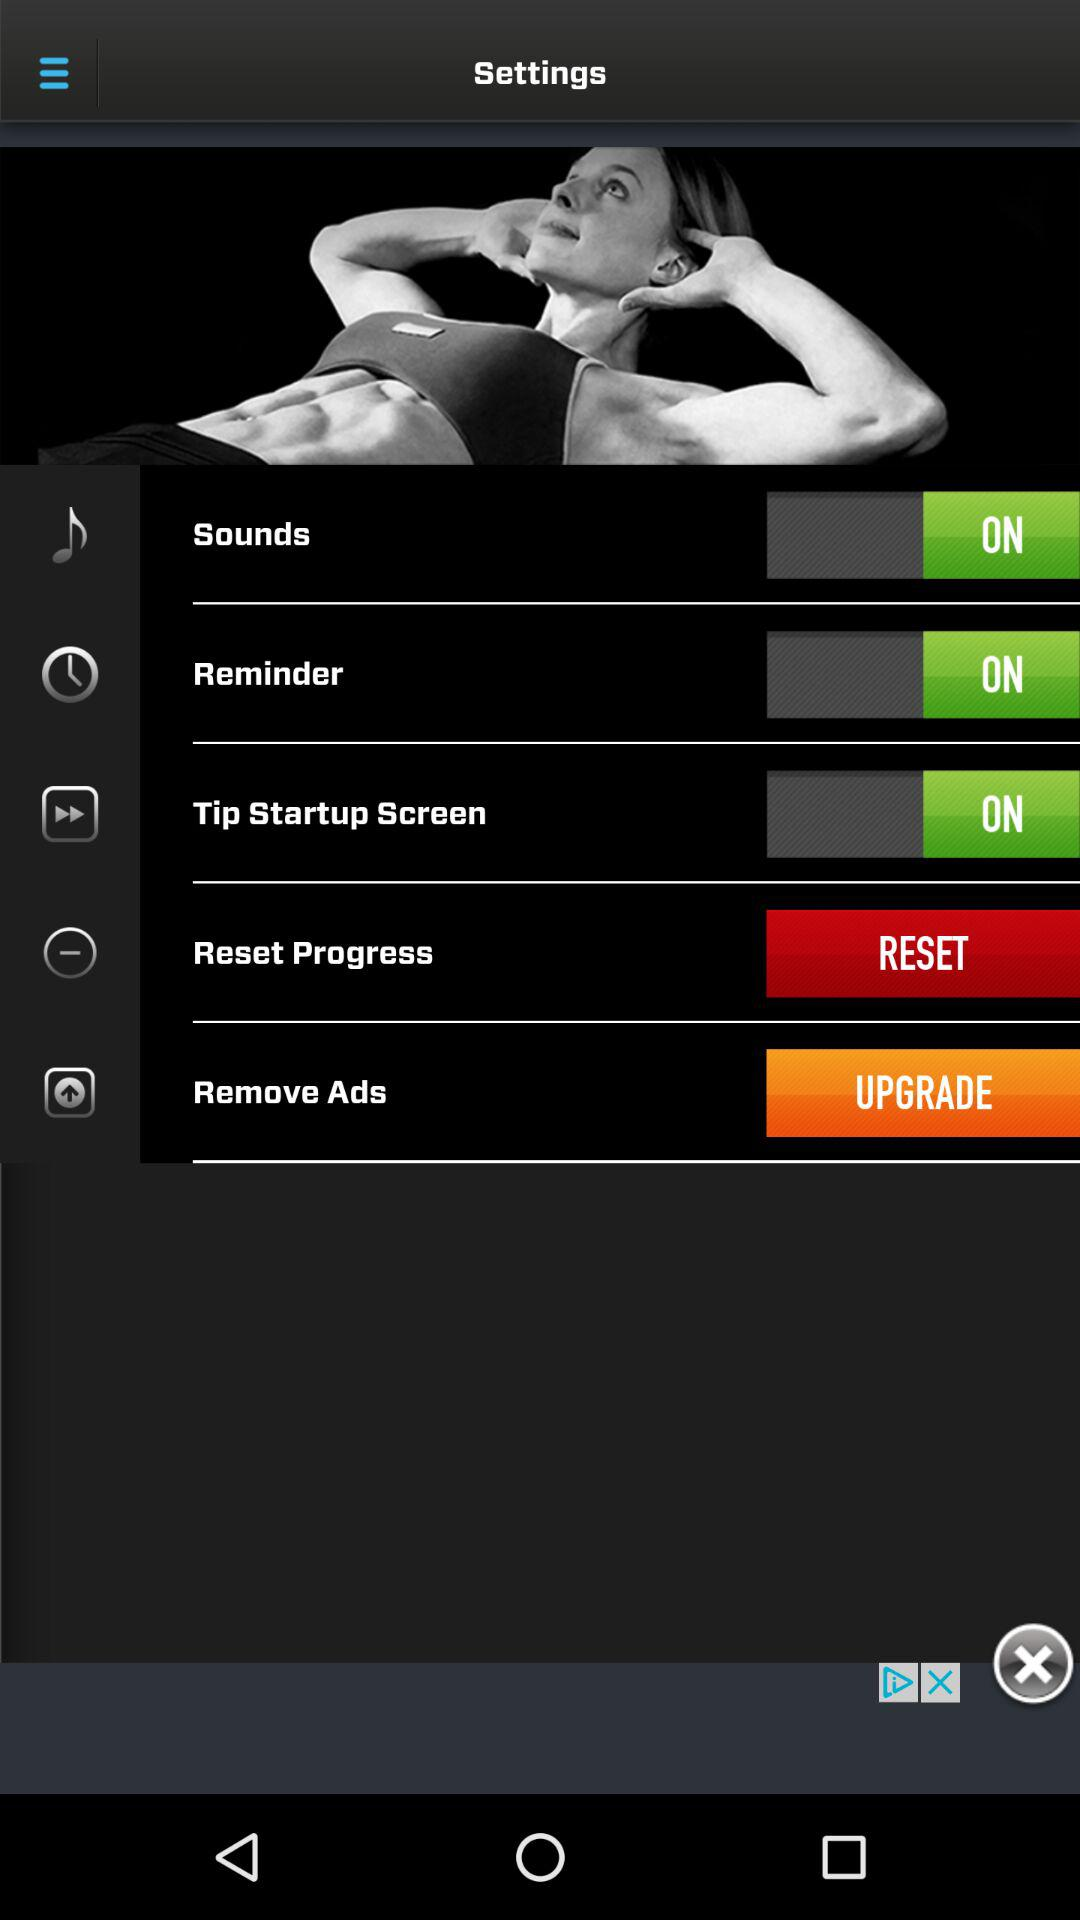What is the current status of the "Sounds" settings? The current status is "on". 